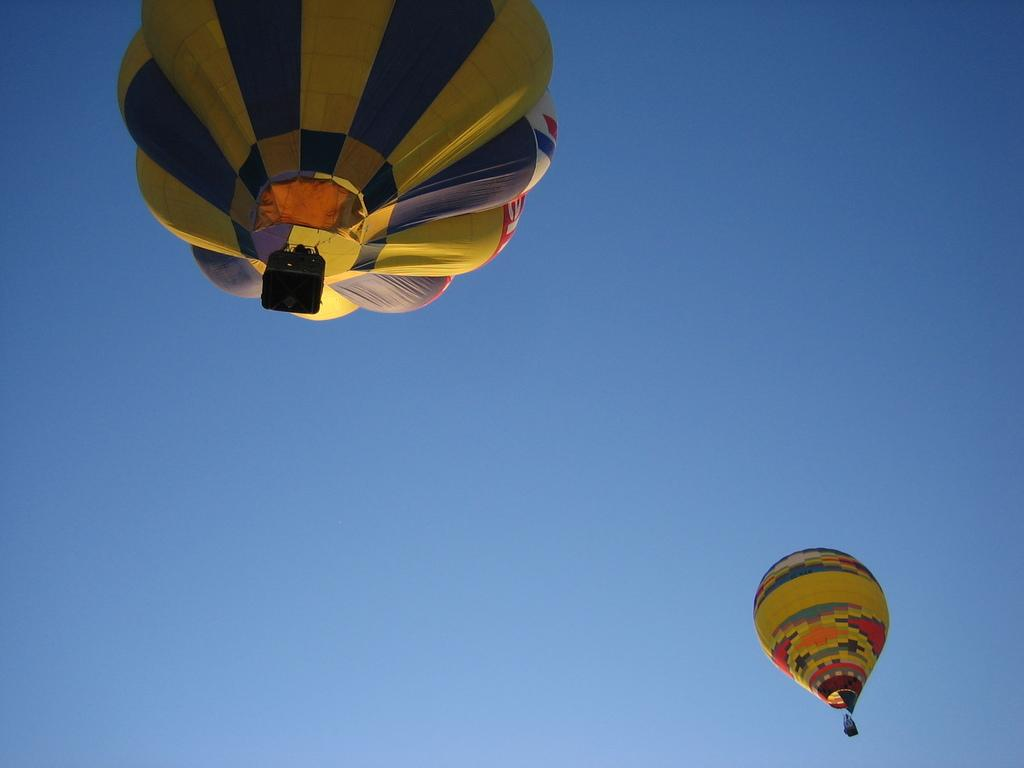What are the main subjects in the image? There are hot air balloons in the image. Where are the hot air balloons located? The hot air balloons are in the air. What type of disgusting creature can be seen crawling on the hot air balloons in the image? There are no creatures, disgusting or otherwise, present on the hot air balloons in the image. What type of jewel can be seen hanging from the hot air balloons in the image? There are no jewels present on the hot air balloons in the image. 